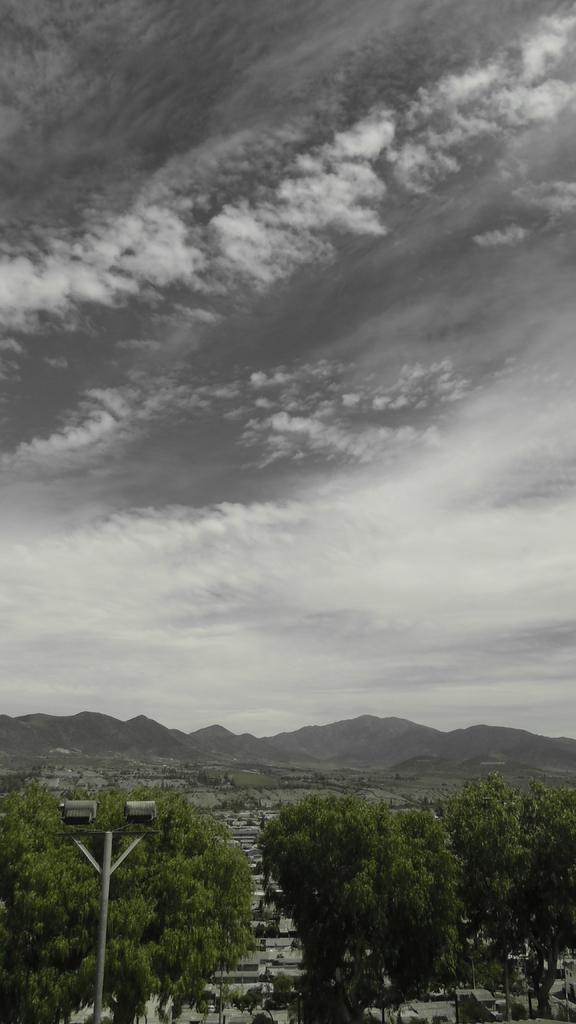What can be seen in the image that provides illumination? There are lights in the image. What structure is present in the image that supports the lights? There is a pole in the image. What type of natural vegetation is visible in the image? There are trees in the image. What type of geographical feature can be seen in the distance? There are mountains in the image. What is visible in the background of the image? The sky is visible in the background of the image. Where is the river flowing in the image? There is no river present in the image. What type of bead is hanging from the pole in the image? There are no beads present in the image; only lights are attached to the pole. 